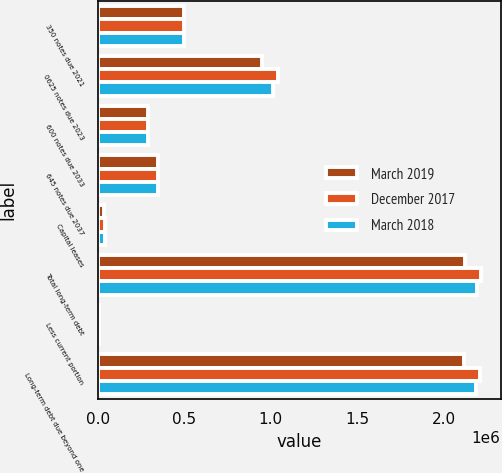Convert chart. <chart><loc_0><loc_0><loc_500><loc_500><stacked_bar_chart><ecel><fcel>350 notes due 2021<fcel>0625 notes due 2023<fcel>600 notes due 2033<fcel>645 notes due 2037<fcel>Capital leases<fcel>Total long-term debt<fcel>Less current portion<fcel>Long-term debt due beyond one<nl><fcel>March 2019<fcel>498450<fcel>949049<fcel>292982<fcel>346534<fcel>34132<fcel>2.12115e+06<fcel>5263<fcel>2.11588e+06<nl><fcel>December 2017<fcel>497852<fcel>1.04158e+06<fcel>292648<fcel>346346<fcel>40397<fcel>2.21882e+06<fcel>6265<fcel>2.21256e+06<nl><fcel>March 2018<fcel>497705<fcel>1.0155e+06<fcel>292568<fcel>346300<fcel>41881<fcel>2.19395e+06<fcel>6165<fcel>2.18779e+06<nl></chart> 